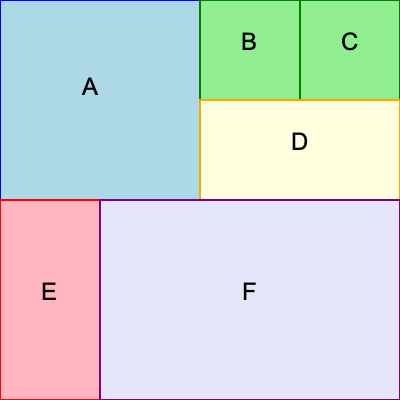Given the grid-based diagram of a modular furniture system, calculate the total perimeter of all furniture pieces. Assume each grid cell is 1 unit in length and width. Express your answer in terms of grid units. To calculate the total perimeter, we need to sum the exposed sides of each furniture piece:

1. Piece A (2x2 grid):
   Perimeter = 2 + 2 + 2 + 2 = 8 units

2. Piece B (1x1 grid):
   Perimeter = 1 + 1 + 1 + 1 = 4 units

3. Piece C (1x1 grid):
   Perimeter = 1 + 1 + 1 + 1 = 4 units

4. Piece D (2x1 grid):
   Perimeter = 2 + 1 + 2 + 1 = 6 units

5. Piece E (1x2 grid):
   Perimeter = 1 + 2 + 1 + 2 = 6 units

6. Piece F (3x2 grid):
   Perimeter = 3 + 2 + 3 + 2 = 10 units

Total perimeter = 8 + 4 + 4 + 6 + 6 + 10 = 38 units

However, we need to subtract the shared edges:
- Between A and B: 1 unit
- Between B and C: 1 unit
- Between A and E: 2 units
- Between D and F: 1 unit

Total shared edges = 1 + 1 + 2 + 1 = 5 units

Final perimeter = 38 - 5 = 33 units
Answer: 33 units 